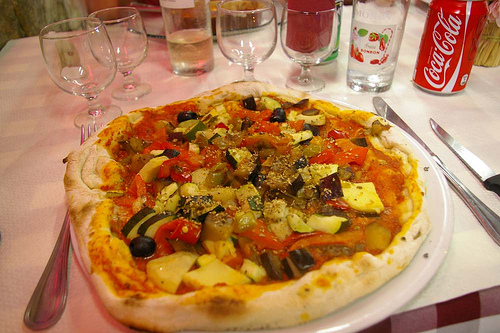What does the presence of a Coca Cola can imply about the meal experience depicted in the image? The presence of a Coca Cola can at the table implies a casual, relaxed dining atmosphere, possibly indicating a quick, enjoyable meal where diners appreciate classic, familiar flavors alongside their food. 